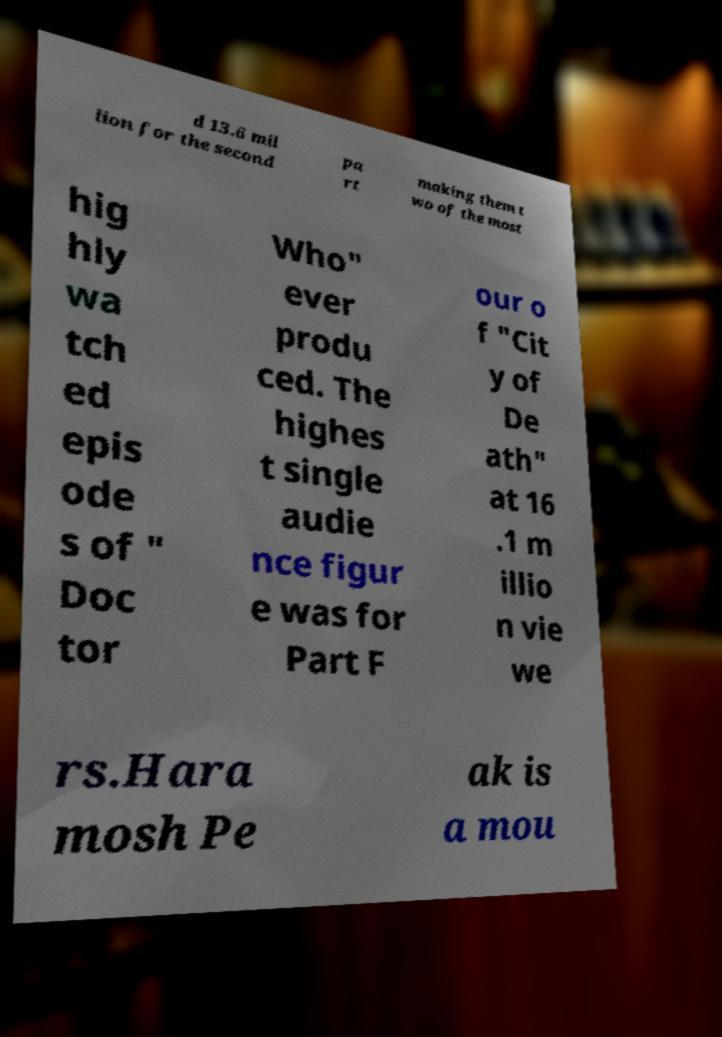Could you extract and type out the text from this image? d 13.6 mil lion for the second pa rt making them t wo of the most hig hly wa tch ed epis ode s of " Doc tor Who" ever produ ced. The highes t single audie nce figur e was for Part F our o f "Cit y of De ath" at 16 .1 m illio n vie we rs.Hara mosh Pe ak is a mou 